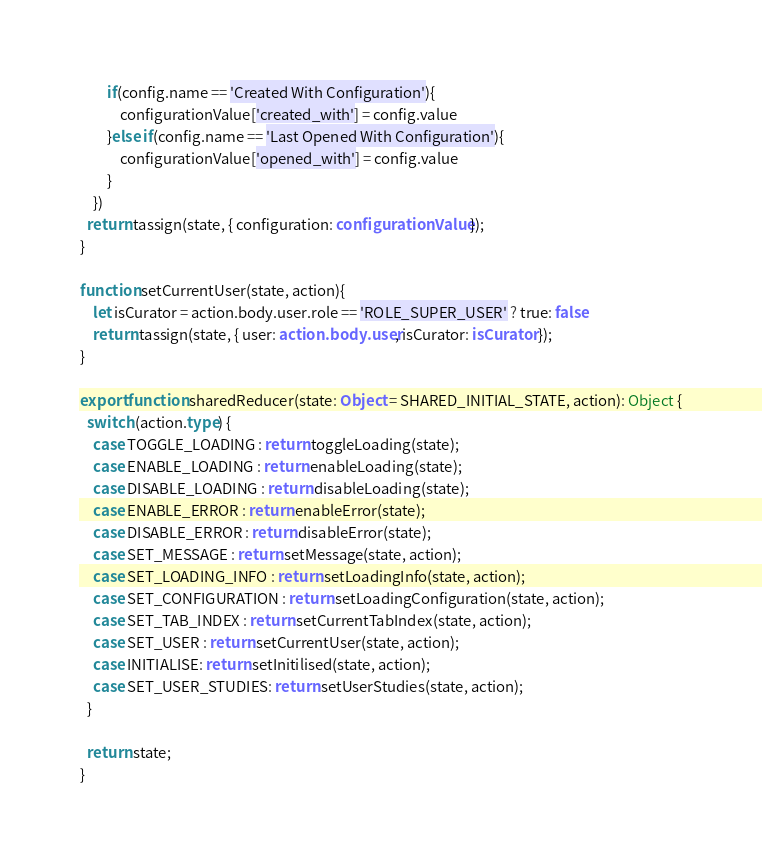<code> <loc_0><loc_0><loc_500><loc_500><_TypeScript_>		if(config.name == 'Created With Configuration'){
			configurationValue['created_with'] = config.value
		}else if(config.name == 'Last Opened With Configuration'){
			configurationValue['opened_with'] = config.value
		}
	})
  return tassign(state, { configuration: configurationValue });
}

function setCurrentUser(state, action){
	let isCurator = action.body.user.role == 'ROLE_SUPER_USER' ? true: false
	return tassign(state, { user: action.body.user, isCurator: isCurator });
}

export function sharedReducer(state: Object = SHARED_INITIAL_STATE, action): Object {
  switch (action.type) {
    case TOGGLE_LOADING : return toggleLoading(state);
    case ENABLE_LOADING : return enableLoading(state);
    case DISABLE_LOADING : return disableLoading(state);
    case ENABLE_ERROR : return enableError(state);
    case DISABLE_ERROR : return disableError(state);
    case SET_MESSAGE : return setMessage(state, action);
    case SET_LOADING_INFO : return setLoadingInfo(state, action);
    case SET_CONFIGURATION : return setLoadingConfiguration(state, action);
    case SET_TAB_INDEX : return setCurrentTabIndex(state, action);
    case SET_USER : return setCurrentUser(state, action);
    case INITIALISE: return setInitilised(state, action);
    case SET_USER_STUDIES: return setUserStudies(state, action);
  }

  return state; 
}</code> 